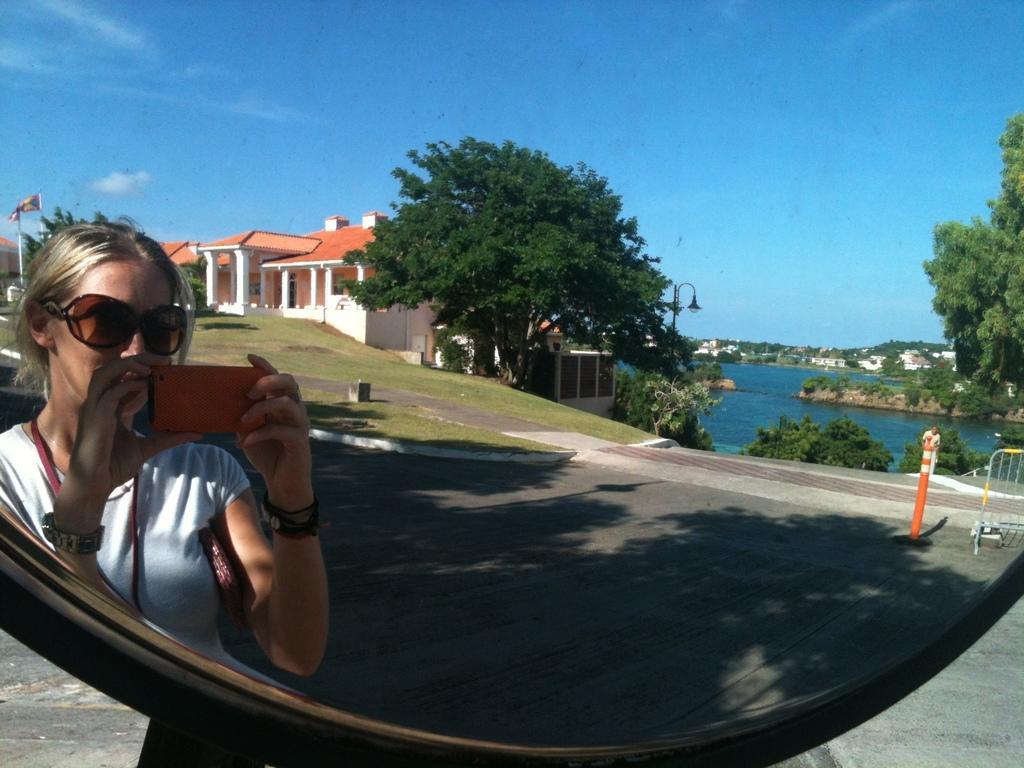Could you give a brief overview of what you see in this image? In the image we can see a mirror. In the mirror, we can see the reflection of a woman wearing clothes, wristwatch, bracelet, goggles and she is holding a device in her hand. This is a road, road barrier, grass, building, flag, trees, water, plant and a sky. 